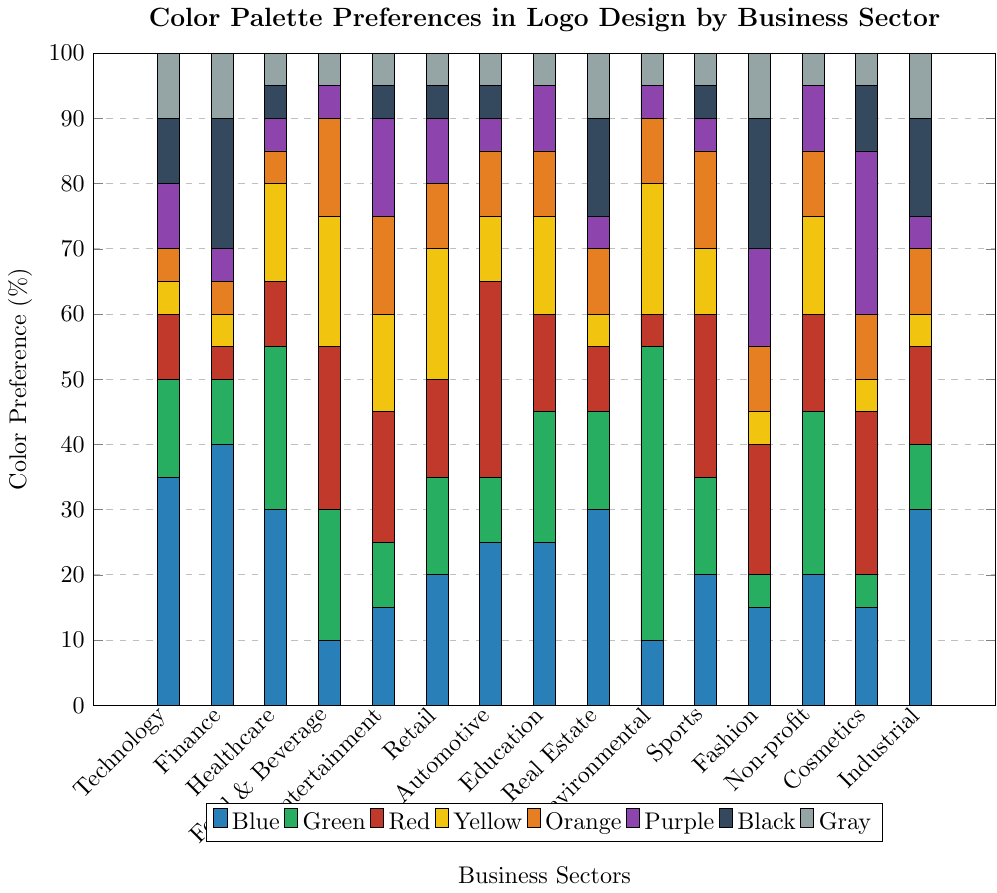Which business sector uses blue the most in logo design? To determine this, find the business sector with the highest blue bar. From the figure, Finance has the highest blue at 40%.
Answer: Finance Which color is least preferred by the Environmental sector? Look for the color with the smallest bar for Environmental. Black and Gray both at 0%.
Answer: Black or Gray Compare the usage of green in the Healthcare and Environmental sectors. Which sector uses it more? Check the height of the green bars in Healthcare and Environmental sectors. Healthcare's green is 25%, and Environmental's green is 45%.
Answer: Environmental What is the total percentage of black used across all sectors? Add the values for black in each sector: 10 + 20 + 5 + 0 + 5 + 5 + 5 + 0 + 15 + 0 + 5 + 20 + 0 + 10 + 15 = 115%.
Answer: 115% For the Fashion sector, which color is used the least and the most? Look at the bars for the Fashion sector. The most is Black at 20%, and the least is Green at 5%.
Answer: Most: Black, Least: Green Which two colors have equal usage in the Retail sector? Identify the colors with the same bar height in Retail. Yellow and Green are both at 20%.
Answer: Yellow and Green Calculate the average preference for purple across all sectors. Sum all purple values and divide by the number of sectors. (10 + 5 + 5 + 5 + 15 + 10 + 5 + 10 + 5 + 5 + 5 + 15 + 10 + 25 + 5) / 15 = 140 / 15 ≈ 9.33%.
Answer: 9.33% Which sector has the highest preference for red and how does it compare with the sector with the lowest preference for red? The highest preference is Automotive at 30% and the lowest is Environmental at 5%. The difference is 30 - 5 = 25%.
Answer: Highest: Automotive; Difference: 25% In the Entertainment sector, what is the combined percentage for blue, green, and red? Add the percentages for blue, green, and red: 15 (blue) + 10 (green) + 20 (red) = 45%.
Answer: 45% How does the usage of yellow in Healthcare compare with that in Sports? Compare the yellow bars: Healthcare is 15%, and Sports is 10%. Healthcare uses 5% more.
Answer: Healthcare uses 5% more 